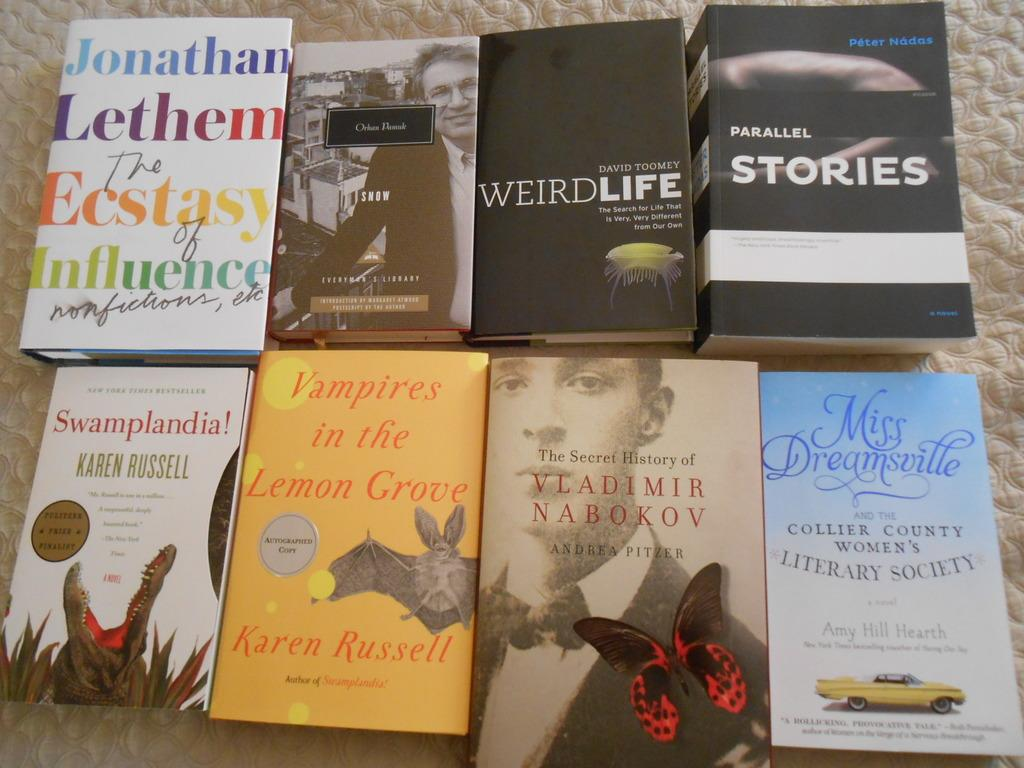Provide a one-sentence caption for the provided image. books displayed on a white bed spread include Weird Life. 